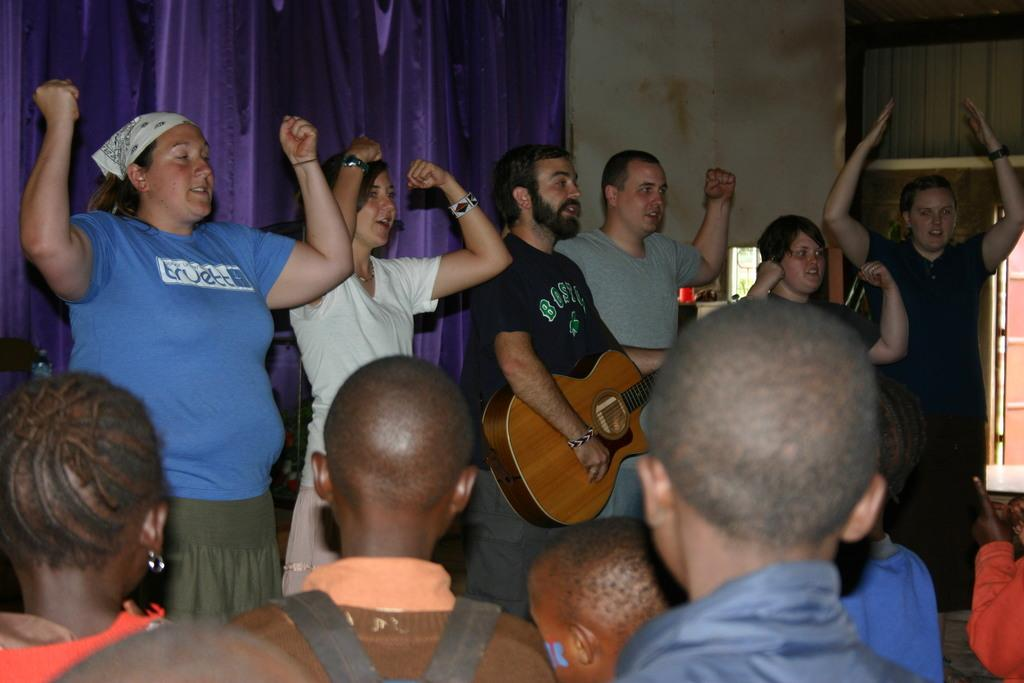What are the people in the image doing? One person is playing a guitar, and another person is carrying a bag. Can you describe the background of the image? There is a purple color curtain in the background. What type of dinner is being served in the image? There is no dinner present in the image; it features people standing and engaging in activities. In which direction are the people facing in the image? The provided facts do not specify the direction the people are facing, so it cannot be determined from the image. 